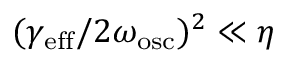<formula> <loc_0><loc_0><loc_500><loc_500>( \gamma _ { e f f } / 2 \omega _ { o s c } ) ^ { 2 } \ll \eta</formula> 